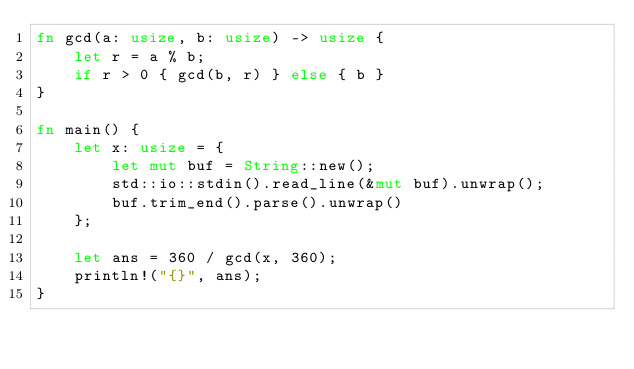<code> <loc_0><loc_0><loc_500><loc_500><_Rust_>fn gcd(a: usize, b: usize) -> usize {
    let r = a % b;
    if r > 0 { gcd(b, r) } else { b }
}

fn main() {
    let x: usize = {
        let mut buf = String::new();
        std::io::stdin().read_line(&mut buf).unwrap();
        buf.trim_end().parse().unwrap()
    };

    let ans = 360 / gcd(x, 360);
    println!("{}", ans);
}</code> 